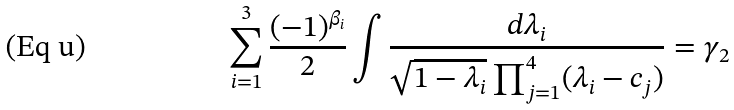Convert formula to latex. <formula><loc_0><loc_0><loc_500><loc_500>\sum _ { i = 1 } ^ { 3 } \frac { ( - 1 ) ^ { \beta _ { i } } } { 2 } \int \frac { d \lambda _ { i } } { \sqrt { 1 - \lambda _ { i } } \prod _ { j = 1 } ^ { 4 } ( \lambda _ { i } - c _ { j } ) } = \gamma _ { 2 }</formula> 